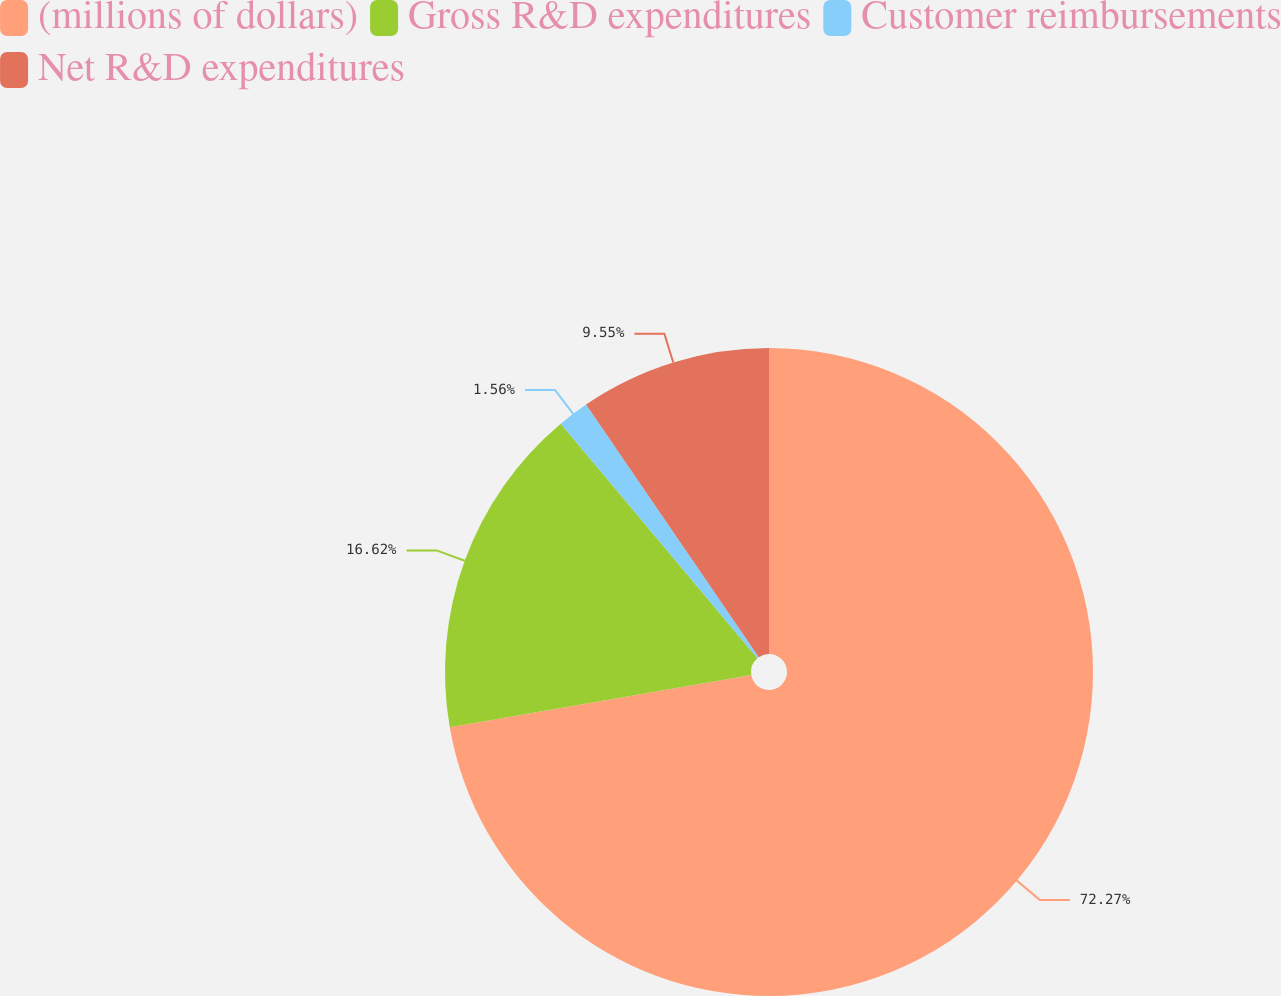Convert chart to OTSL. <chart><loc_0><loc_0><loc_500><loc_500><pie_chart><fcel>(millions of dollars)<fcel>Gross R&D expenditures<fcel>Customer reimbursements<fcel>Net R&D expenditures<nl><fcel>72.27%<fcel>16.62%<fcel>1.56%<fcel>9.55%<nl></chart> 